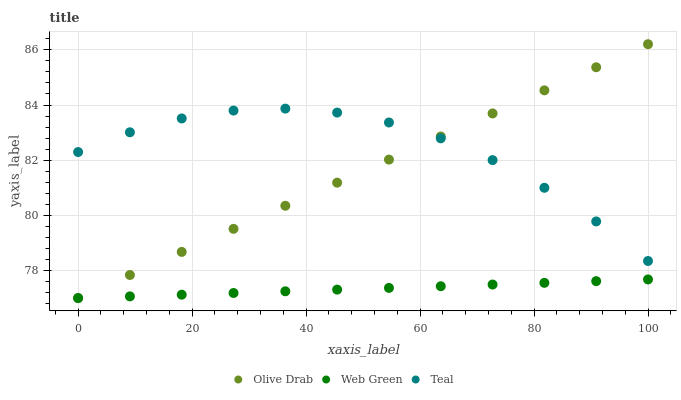Does Web Green have the minimum area under the curve?
Answer yes or no. Yes. Does Teal have the maximum area under the curve?
Answer yes or no. Yes. Does Olive Drab have the minimum area under the curve?
Answer yes or no. No. Does Olive Drab have the maximum area under the curve?
Answer yes or no. No. Is Web Green the smoothest?
Answer yes or no. Yes. Is Teal the roughest?
Answer yes or no. Yes. Is Olive Drab the smoothest?
Answer yes or no. No. Is Olive Drab the roughest?
Answer yes or no. No. Does Web Green have the lowest value?
Answer yes or no. Yes. Does Olive Drab have the highest value?
Answer yes or no. Yes. Does Web Green have the highest value?
Answer yes or no. No. Is Web Green less than Teal?
Answer yes or no. Yes. Is Teal greater than Web Green?
Answer yes or no. Yes. Does Olive Drab intersect Web Green?
Answer yes or no. Yes. Is Olive Drab less than Web Green?
Answer yes or no. No. Is Olive Drab greater than Web Green?
Answer yes or no. No. Does Web Green intersect Teal?
Answer yes or no. No. 